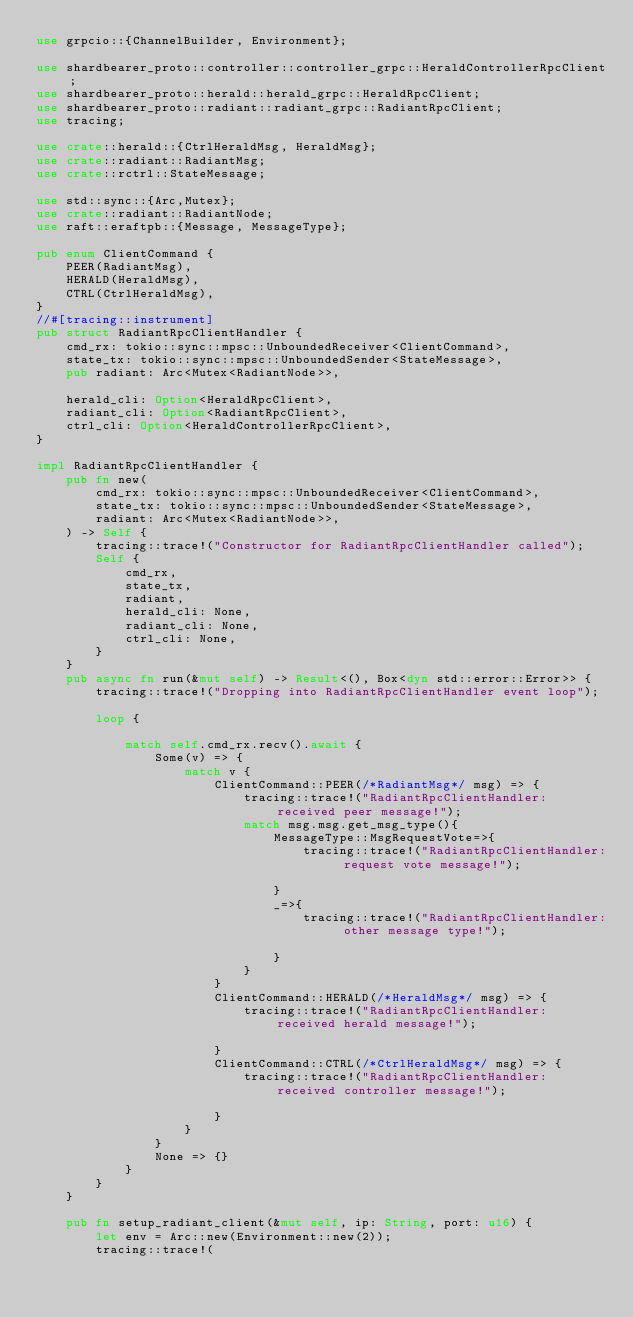Convert code to text. <code><loc_0><loc_0><loc_500><loc_500><_Rust_>use grpcio::{ChannelBuilder, Environment};

use shardbearer_proto::controller::controller_grpc::HeraldControllerRpcClient;
use shardbearer_proto::herald::herald_grpc::HeraldRpcClient;
use shardbearer_proto::radiant::radiant_grpc::RadiantRpcClient;
use tracing;

use crate::herald::{CtrlHeraldMsg, HeraldMsg};
use crate::radiant::RadiantMsg;
use crate::rctrl::StateMessage;

use std::sync::{Arc,Mutex};
use crate::radiant::RadiantNode;
use raft::eraftpb::{Message, MessageType};

pub enum ClientCommand {
    PEER(RadiantMsg),
    HERALD(HeraldMsg),
    CTRL(CtrlHeraldMsg),
}
//#[tracing::instrument]
pub struct RadiantRpcClientHandler {
    cmd_rx: tokio::sync::mpsc::UnboundedReceiver<ClientCommand>,
    state_tx: tokio::sync::mpsc::UnboundedSender<StateMessage>,
    pub radiant: Arc<Mutex<RadiantNode>>,

    herald_cli: Option<HeraldRpcClient>,
    radiant_cli: Option<RadiantRpcClient>,
    ctrl_cli: Option<HeraldControllerRpcClient>,
}

impl RadiantRpcClientHandler {
    pub fn new(
        cmd_rx: tokio::sync::mpsc::UnboundedReceiver<ClientCommand>,
        state_tx: tokio::sync::mpsc::UnboundedSender<StateMessage>,
        radiant: Arc<Mutex<RadiantNode>>,
    ) -> Self {
        tracing::trace!("Constructor for RadiantRpcClientHandler called");
        Self {
            cmd_rx,
            state_tx,
            radiant,
            herald_cli: None,
            radiant_cli: None,
            ctrl_cli: None,
        }
    }
    pub async fn run(&mut self) -> Result<(), Box<dyn std::error::Error>> {
        tracing::trace!("Dropping into RadiantRpcClientHandler event loop");

        loop {

            match self.cmd_rx.recv().await {
                Some(v) => {
                    match v {
                        ClientCommand::PEER(/*RadiantMsg*/ msg) => {
                            tracing::trace!("RadiantRpcClientHandler: received peer message!");
                            match msg.msg.get_msg_type(){
                                MessageType::MsgRequestVote=>{
                                    tracing::trace!("RadiantRpcClientHandler: request vote message!");

                                }
                                _=>{
                                    tracing::trace!("RadiantRpcClientHandler: other message type!");

                                }
                            }
                        }
                        ClientCommand::HERALD(/*HeraldMsg*/ msg) => {
                            tracing::trace!("RadiantRpcClientHandler: received herald message!");

                        }
                        ClientCommand::CTRL(/*CtrlHeraldMsg*/ msg) => {
                            tracing::trace!("RadiantRpcClientHandler: received controller message!");

                        }
                    }
                }
                None => {}
            }
        }
    }

    pub fn setup_radiant_client(&mut self, ip: String, port: u16) {
        let env = Arc::new(Environment::new(2));
        tracing::trace!(</code> 